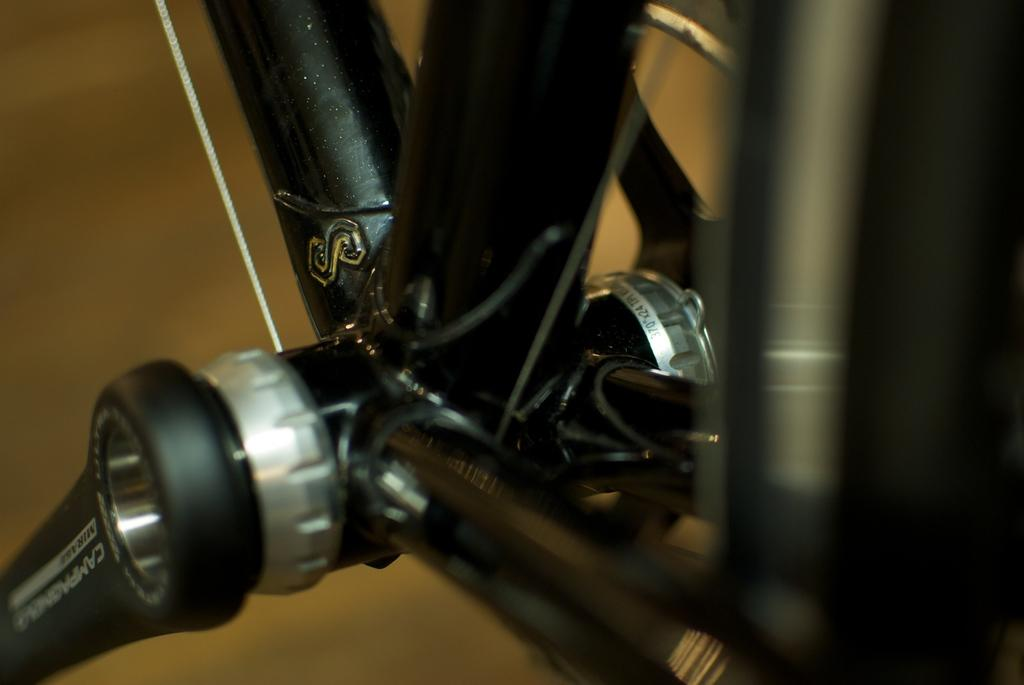What objects can be seen in the image that are related to construction or crafting? In the image, there are rods and strings, which can be used for construction or crafting. What letter is visible in the image? The letter "S" is visible in the image. What type of vehicle component is present in the image? There is a tire in the image. How would you describe the clarity of the right side of the image? The right side of the image is blurred. How would you describe the overall clarity of the image? The background of the image is blurry. What type of bucket is being used in the meeting depicted in the image? There is no meeting or bucket present in the image. 